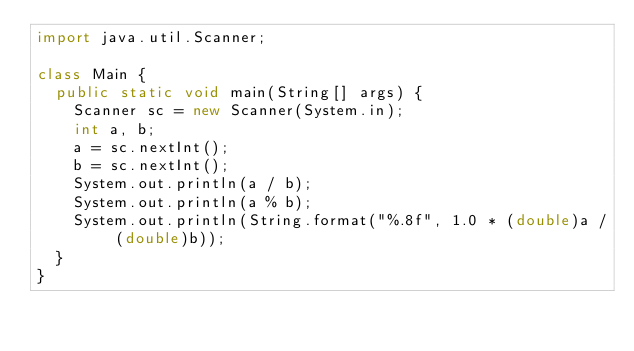Convert code to text. <code><loc_0><loc_0><loc_500><loc_500><_Java_>import java.util.Scanner;

class Main {
	public static void main(String[] args) {
		Scanner sc = new Scanner(System.in);
		int a, b;
		a = sc.nextInt();
		b = sc.nextInt();
		System.out.println(a / b);
		System.out.println(a % b);
		System.out.println(String.format("%.8f", 1.0 * (double)a / (double)b));
	}
}

</code> 